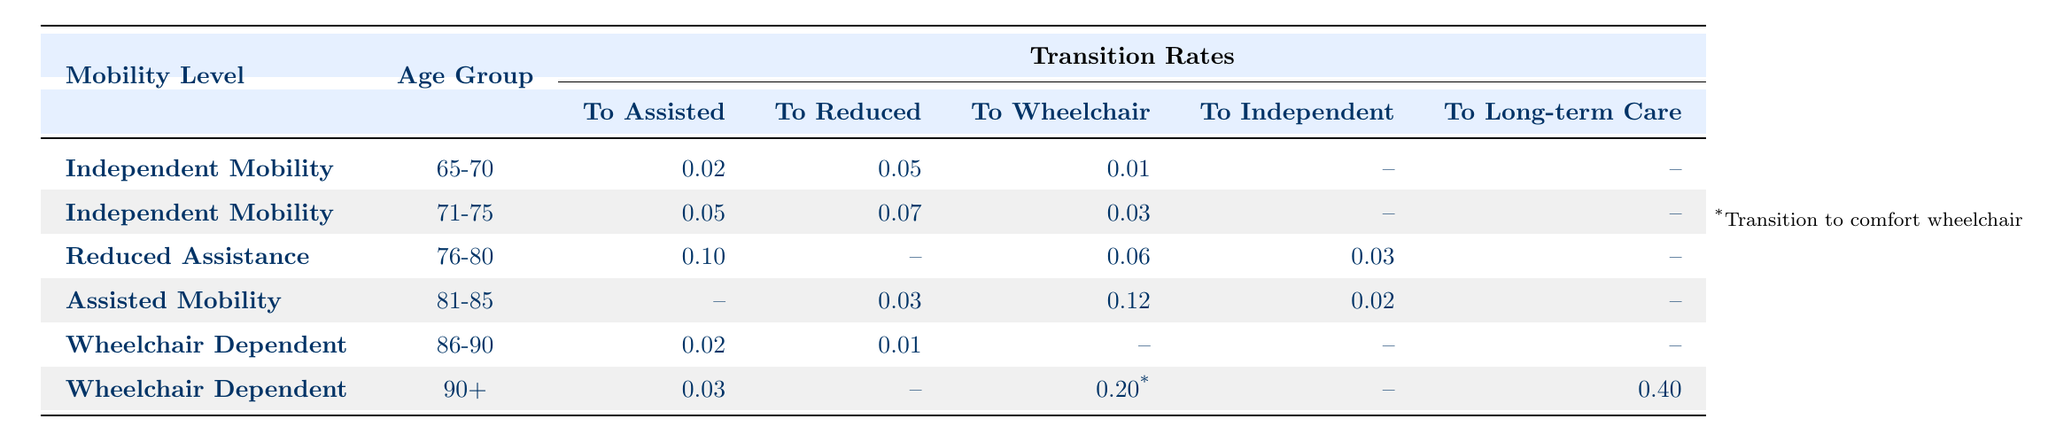What are the transition rates from Independent Mobility to Assisted Mobility for the age group 65-70? According to the table, the transition rate from Independent Mobility to Assisted Mobility for the age group 65-70 is 0.02.
Answer: 0.02 What is the transition rate from Assisted Mobility to Wheelchair Dependent for the age group 81-85? The table indicates that there are no transitions from Assisted Mobility to Wheelchair Dependent for the age group 81-85, as it shows a value of "--".
Answer: No What is the age group with the highest transition rate to Wheelchair for those in Reduced Assistance? The age group 76-80 shows a transition rate of 0.06 to Wheelchair for Reduced Assistance. No other age group in the table indicates a higher value for Wheelchair transitions.
Answer: 76-80 What is the total transition rate from Assisted Mobility for the age group 81-85? The table shows 0.02 (to Independent), 0.03 (to Reduced Assistance), and 0.12 (to Wheelchair), so the total transition rate is 0.02 + 0.03 + 0.12 = 0.17.
Answer: 0.17 Is the transition rate from Wheelchair Dependent to Long-term Care for age group 90+ greater than 0.3? The transition rate from Wheelchair Dependent to Long-term Care for age group 90+ is 0.40. Since 0.40 is greater than 0.3, the statement is true.
Answer: Yes What is the comparison of transition rates to Comfort Wheelchair between age groups 86-90 and 90+? The rate for age group 86-90 is 0.15 while for age group 90+ it is 0.20. Comparing these rates, 0.20 is greater than 0.15, indicating a higher transition rate for the older age group.
Answer: 90+ What is the total probability of transitions for those 71-75 years of age in the Independent Mobility category? For age group 71-75, the transition rates are 0.05 (to Assisted), 0.07 (to Reduced Assistance), and 0.03 (to Wheelchair), leading to a total of 0.05 + 0.07 + 0.03 = 0.15.
Answer: 0.15 For which mobility level does the highest transition to reduced assistance occur, and what is the rate? The highest transition to Reduced Assistance occurs in the age group 71-75 with a rate of 0.07 for Independent Mobility.
Answer: Independent Mobility, 0.07 What are the possible transitions from Wheelchair Dependent for age group 86-90? The possible transitions from Wheelchair Dependent for age group 86-90 are to Reduced Assistance (0.01), Assisted (0.02), and Comfort Wheelchair (0.15), totaling three transition options.
Answer: 3 